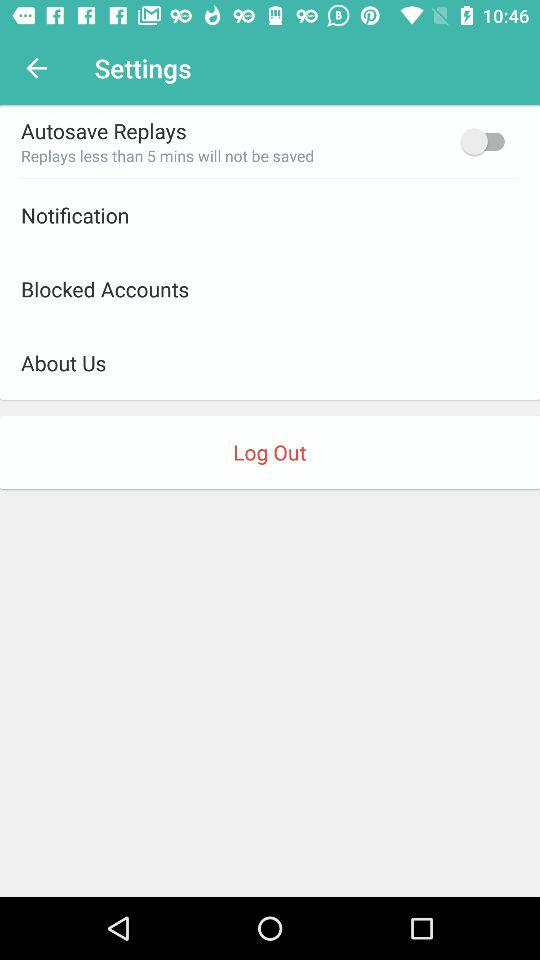What is the status of "Autosave Replays"? The status of "Autosave Replays" is "off". 